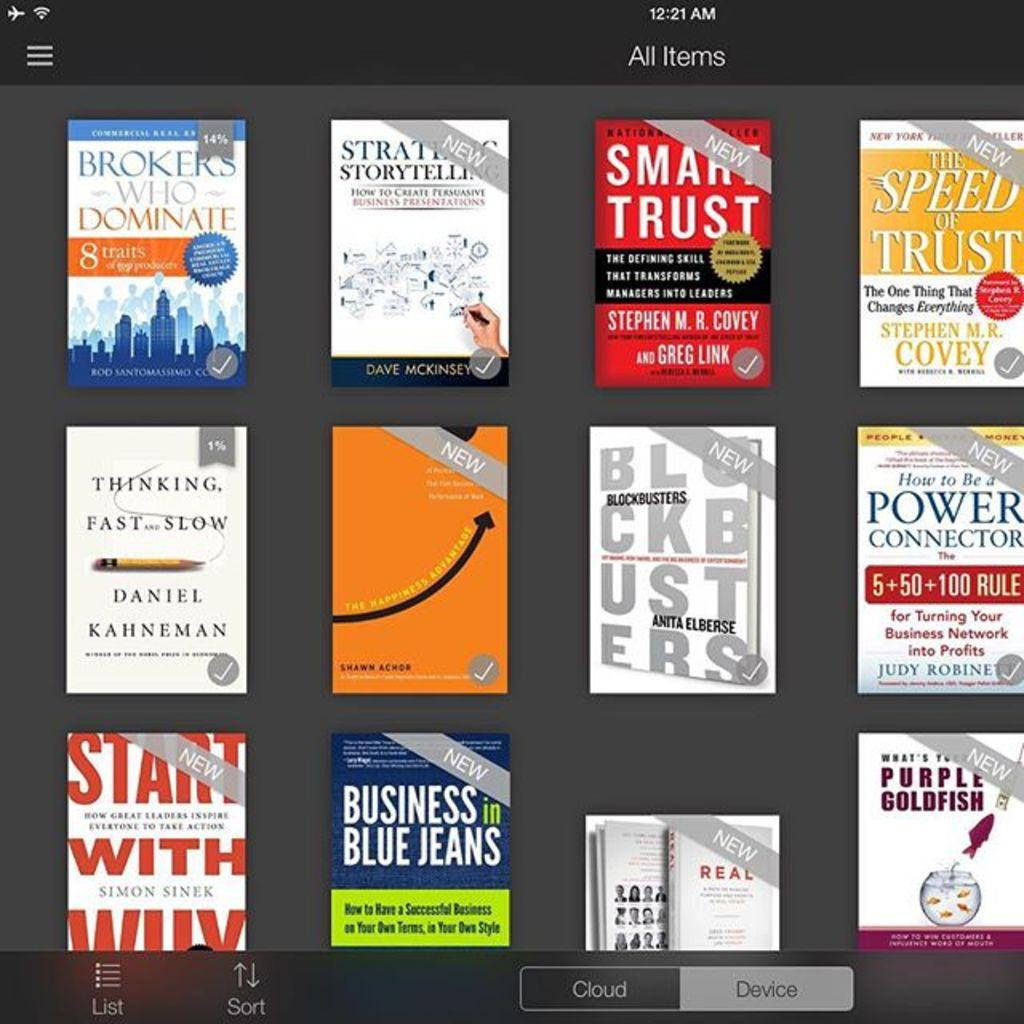<image>
Create a compact narrative representing the image presented. the words speed of trust are on the book 